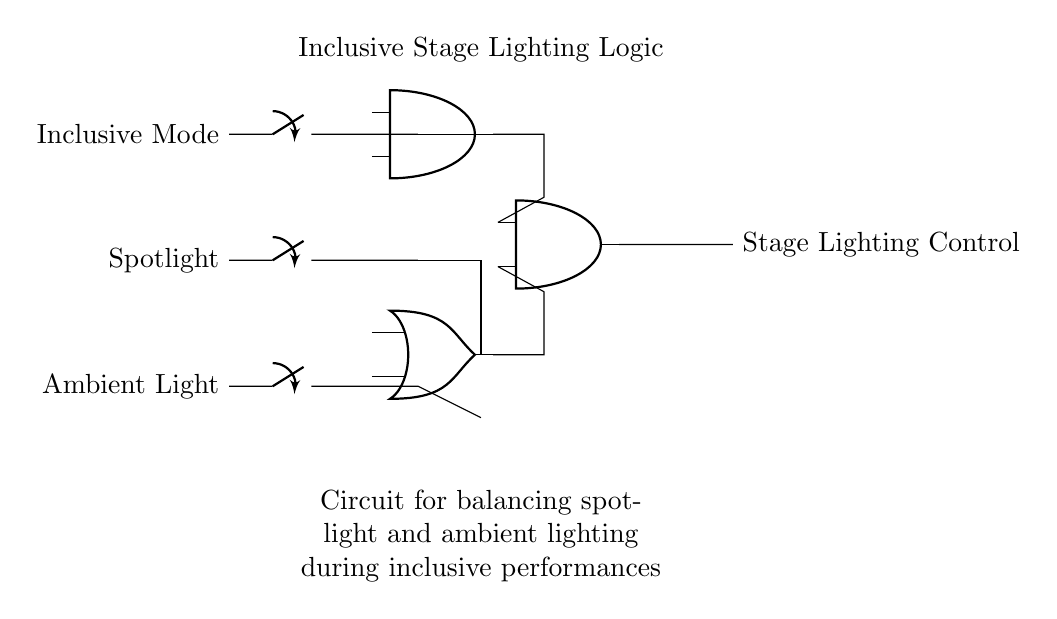What are the inputs to the circuit? The inputs to the circuit are "Inclusive Mode," "Spotlight," and "Ambient Light," each indicated by a switch on the left side of the circuit diagram.
Answer: Inclusive Mode, Spotlight, Ambient Light How many logic gates are there in this circuit? The circuit has three logic gates: one AND gate and two OR gates, which are shown as symbols in the diagram.
Answer: Three What is the output of the circuit? The output of the circuit is labeled "Stage Lighting Control" on the right side, indicating what the logic gates are controlling.
Answer: Stage Lighting Control What happens if the "Inclusive Mode" switch is turned ON? If the "Inclusive Mode" switch is ON, it affects the AND gate, allowing its output to potentially control the stage lighting based on the other inputs.
Answer: AND gate activates Which logic gate combines "Spotlight" and "Ambient Light"? The "Spotlight" and "Ambient Light" inputs are combined by an OR gate, shown in the middle section of the circuit diagram, connecting to the input of the second AND gate.
Answer: OR gate What does the diagram ensure during performances? The diagram ensures that both spotlight and ambient light are balanced while maintaining inclusivity in the performance environment, which is crucial for accessibility.
Answer: Balancing lighting What is the purpose of using an AND gate with the two major inputs? The AND gate processes the "Inclusive Mode" input with the other combined inputs to ensure stage lighting is only activated when both conditions are fulfilled, thus enhancing the experience of inclusive performances.
Answer: Ensure both conditions fulfilled 